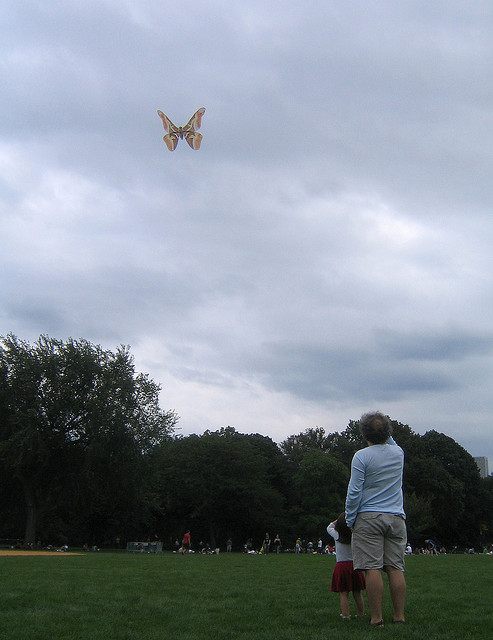<image>What does this animal provide to us? I don't know what the animal provides to us. It depends on the animal. Which direction is the wind blowing? It is unknown which direction the wind is blowing. It could be east, west, north, or even left. In what city is this man flying his kite? I don't know in what city this man is flying his kite. It can be any city such as 'London', 'Atlanta', 'Seattle' or 'Pyongyang'. What does this animal provide to us? I am not sure what does this animal provide to us. It can be beauty, pollination, fun, or joy. Which direction is the wind blowing? I don't know which direction the wind is blowing. It can be either west or east. In what city is this man flying his kite? I don't know in what city the man is flying his kite. It can be seen in London, Atlanta, Seattle or Pyongyang. 